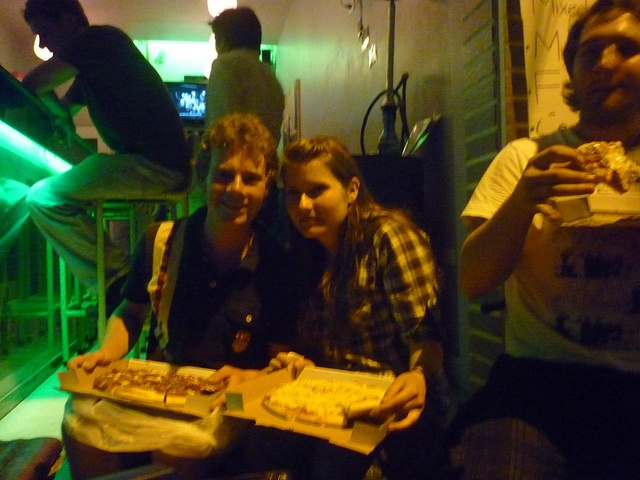Describe the objects in this image and their specific colors. I can see people in brown, black, maroon, olive, and orange tones, people in brown, black, olive, maroon, and orange tones, people in brown, black, darkgreen, olive, and green tones, people in brown, black, maroon, olive, and orange tones, and people in brown, black, and darkgreen tones in this image. 